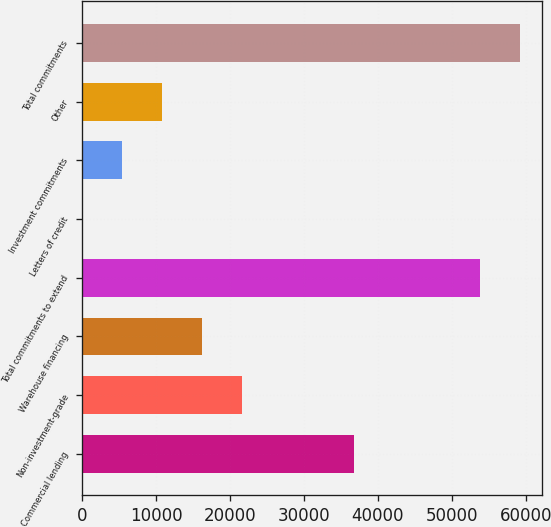Convert chart to OTSL. <chart><loc_0><loc_0><loc_500><loc_500><bar_chart><fcel>Commercial lending<fcel>Non-investment-grade<fcel>Warehouse financing<fcel>Total commitments to extend<fcel>Letters of credit<fcel>Investment commitments<fcel>Other<fcel>Total commitments<nl><fcel>36811<fcel>21569.4<fcel>16177.8<fcel>53822<fcel>3<fcel>5394.6<fcel>10786.2<fcel>59213.6<nl></chart> 